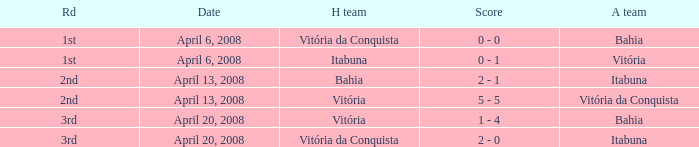Who played as the home team when Vitória was the away team? Itabuna. 